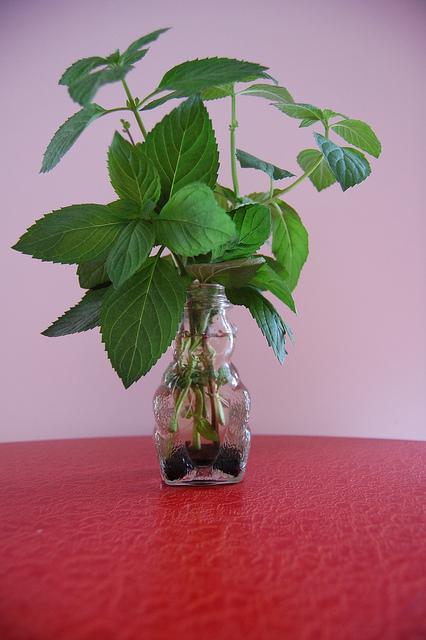What color is the plant?
Quick response, please. Green. How many flower arrangements are in the scene?
Write a very short answer. 1. How many clear containers are there?
Give a very brief answer. 1. Has the tablecloth been ironed?
Short answer required. No. Could a fish live in there?
Concise answer only. No. What is in the vase?
Answer briefly. Plant. What type of plant is this?
Write a very short answer. Mint. 